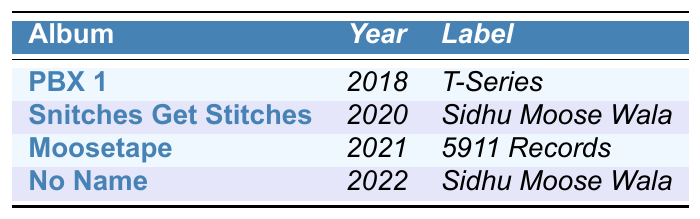What is the title of Sidhu Moose Wala's first studio album? The first studio album listed in the table is "PBX 1," which was released in 2018.
Answer: PBX 1 Which album was released in 2020? The album released in 2020, as per the table, is "Snitches Get Stitches."
Answer: Snitches Get Stitches How many studio albums has Sidhu Moose Wala released up to 2022? There are four studio albums listed in the table: "PBX 1," "Snitches Get Stitches," "Moosetape," and "No Name."
Answer: Four What record label released "Moosetape"? The table indicates that "Moosetape" was released under the label "5911 Records."
Answer: 5911 Records In which year was the album "No Name" released? According to the table, "No Name" was released in 2022.
Answer: 2022 Which studio album has the record label "Sidhu Moose Wala"? The albums labeled under "Sidhu Moose Wala" are "Snitches Get Stitches" and "No Name."
Answer: Snitches Get Stitches, No Name What is the average release year of Sidhu Moose Wala's albums? The years of release are 2018, 2020, 2021, and 2022. To find the average, sum these years (2018 + 2020 + 2021 + 2022) = 8081, and then divide by 4 (8081 / 4) which equals 2020.25.
Answer: 2020.25 Is "PBX 1" the only album released under the label "T-Series"? Yes, according to the table, "PBX 1" is the only album listed under "T-Series."
Answer: Yes Which album was released last before 2022? The album released immediately before 2022 in the table is "Moosetape," which came out in 2021.
Answer: Moosetape How many albums were released by Sidhu Moose Wala from 2018 to 2021? The albums released between 2018 and 2021 include "PBX 1" (2018), "Snitches Get Stitches" (2020), and "Moosetape" (2021), which totals three albums.
Answer: Three 